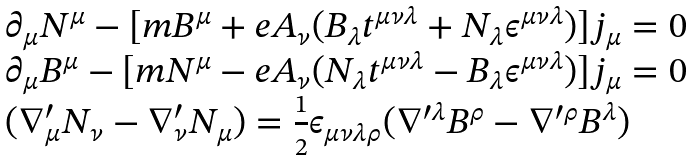<formula> <loc_0><loc_0><loc_500><loc_500>\begin{array} { l } \partial _ { \mu } N ^ { \mu } - [ m B ^ { \mu } + e A _ { \nu } ( B _ { \lambda } t ^ { \mu \nu \lambda } + N _ { \lambda } \epsilon ^ { \mu \nu \lambda } ) ] j _ { \mu } = 0 \\ \partial _ { \mu } B ^ { \mu } - [ m N ^ { \mu } - e A _ { \nu } ( N _ { \lambda } t ^ { \mu \nu \lambda } - B _ { \lambda } \epsilon ^ { \mu \nu \lambda } ) ] j _ { \mu } = 0 \\ ( \nabla _ { \mu } ^ { \prime } N _ { \nu } - \nabla _ { \nu } ^ { \prime } N _ { \mu } ) = \frac { 1 } { 2 } \epsilon _ { \mu \nu \lambda \rho } ( \nabla ^ { \prime \lambda } B ^ { \rho } - \nabla ^ { \prime \rho } B ^ { \lambda } ) \end{array}</formula> 